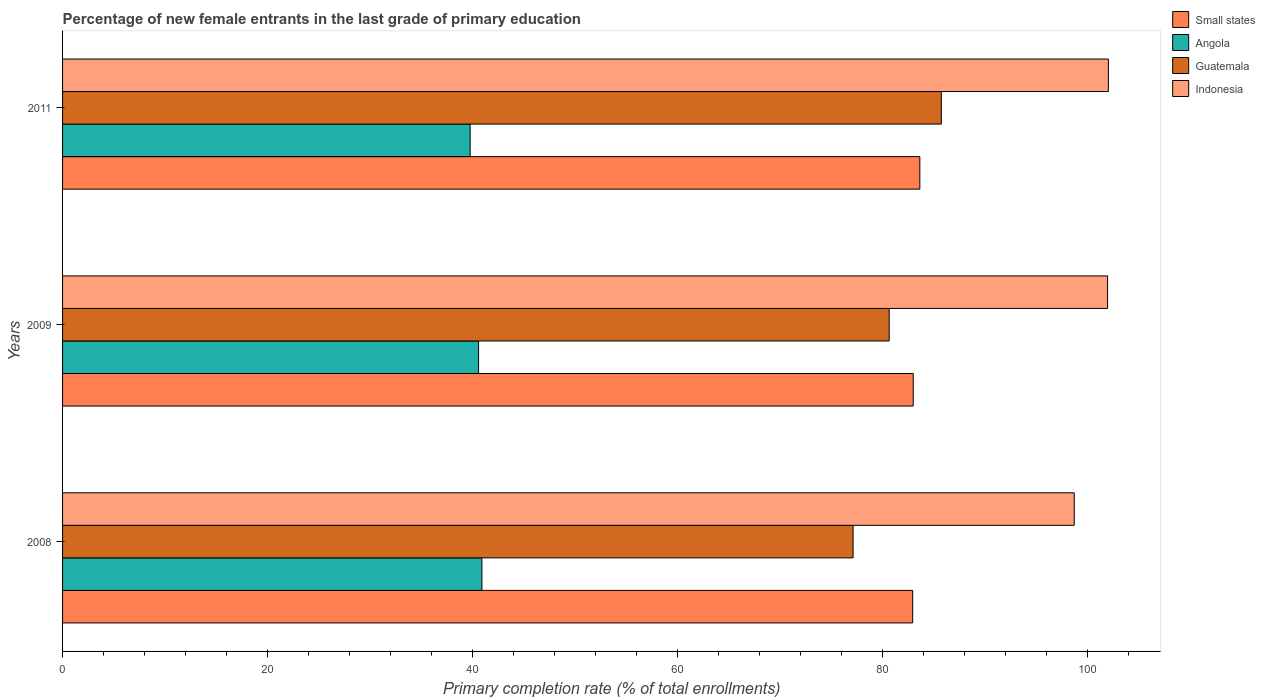Are the number of bars per tick equal to the number of legend labels?
Keep it short and to the point. Yes. How many bars are there on the 3rd tick from the top?
Your response must be concise. 4. How many bars are there on the 1st tick from the bottom?
Your answer should be very brief. 4. What is the percentage of new female entrants in Angola in 2009?
Keep it short and to the point. 40.6. Across all years, what is the maximum percentage of new female entrants in Angola?
Your answer should be very brief. 40.92. Across all years, what is the minimum percentage of new female entrants in Small states?
Your answer should be compact. 82.96. In which year was the percentage of new female entrants in Guatemala maximum?
Give a very brief answer. 2011. What is the total percentage of new female entrants in Guatemala in the graph?
Your answer should be very brief. 243.56. What is the difference between the percentage of new female entrants in Guatemala in 2008 and that in 2011?
Make the answer very short. -8.61. What is the difference between the percentage of new female entrants in Angola in 2009 and the percentage of new female entrants in Indonesia in 2011?
Provide a short and direct response. -61.46. What is the average percentage of new female entrants in Angola per year?
Ensure brevity in your answer.  40.43. In the year 2009, what is the difference between the percentage of new female entrants in Indonesia and percentage of new female entrants in Angola?
Offer a terse response. 61.38. What is the ratio of the percentage of new female entrants in Angola in 2008 to that in 2009?
Your answer should be compact. 1.01. Is the percentage of new female entrants in Indonesia in 2008 less than that in 2011?
Provide a short and direct response. Yes. What is the difference between the highest and the second highest percentage of new female entrants in Small states?
Make the answer very short. 0.65. What is the difference between the highest and the lowest percentage of new female entrants in Guatemala?
Give a very brief answer. 8.61. Is the sum of the percentage of new female entrants in Indonesia in 2008 and 2011 greater than the maximum percentage of new female entrants in Small states across all years?
Offer a very short reply. Yes. Is it the case that in every year, the sum of the percentage of new female entrants in Guatemala and percentage of new female entrants in Small states is greater than the sum of percentage of new female entrants in Indonesia and percentage of new female entrants in Angola?
Your response must be concise. Yes. What does the 1st bar from the top in 2011 represents?
Your answer should be compact. Indonesia. What does the 2nd bar from the bottom in 2011 represents?
Give a very brief answer. Angola. What is the difference between two consecutive major ticks on the X-axis?
Make the answer very short. 20. Are the values on the major ticks of X-axis written in scientific E-notation?
Offer a very short reply. No. Does the graph contain any zero values?
Ensure brevity in your answer.  No. Does the graph contain grids?
Offer a terse response. No. How many legend labels are there?
Provide a short and direct response. 4. What is the title of the graph?
Provide a short and direct response. Percentage of new female entrants in the last grade of primary education. Does "Israel" appear as one of the legend labels in the graph?
Keep it short and to the point. No. What is the label or title of the X-axis?
Offer a terse response. Primary completion rate (% of total enrollments). What is the Primary completion rate (% of total enrollments) of Small states in 2008?
Your answer should be compact. 82.96. What is the Primary completion rate (% of total enrollments) of Angola in 2008?
Make the answer very short. 40.92. What is the Primary completion rate (% of total enrollments) in Guatemala in 2008?
Make the answer very short. 77.14. What is the Primary completion rate (% of total enrollments) in Indonesia in 2008?
Your answer should be compact. 98.72. What is the Primary completion rate (% of total enrollments) in Small states in 2009?
Make the answer very short. 83.01. What is the Primary completion rate (% of total enrollments) in Angola in 2009?
Provide a succinct answer. 40.6. What is the Primary completion rate (% of total enrollments) in Guatemala in 2009?
Offer a terse response. 80.66. What is the Primary completion rate (% of total enrollments) of Indonesia in 2009?
Give a very brief answer. 101.98. What is the Primary completion rate (% of total enrollments) of Small states in 2011?
Keep it short and to the point. 83.66. What is the Primary completion rate (% of total enrollments) of Angola in 2011?
Keep it short and to the point. 39.77. What is the Primary completion rate (% of total enrollments) in Guatemala in 2011?
Keep it short and to the point. 85.75. What is the Primary completion rate (% of total enrollments) in Indonesia in 2011?
Provide a succinct answer. 102.05. Across all years, what is the maximum Primary completion rate (% of total enrollments) of Small states?
Ensure brevity in your answer.  83.66. Across all years, what is the maximum Primary completion rate (% of total enrollments) in Angola?
Offer a terse response. 40.92. Across all years, what is the maximum Primary completion rate (% of total enrollments) in Guatemala?
Provide a succinct answer. 85.75. Across all years, what is the maximum Primary completion rate (% of total enrollments) of Indonesia?
Offer a very short reply. 102.05. Across all years, what is the minimum Primary completion rate (% of total enrollments) in Small states?
Make the answer very short. 82.96. Across all years, what is the minimum Primary completion rate (% of total enrollments) of Angola?
Provide a succinct answer. 39.77. Across all years, what is the minimum Primary completion rate (% of total enrollments) in Guatemala?
Offer a very short reply. 77.14. Across all years, what is the minimum Primary completion rate (% of total enrollments) in Indonesia?
Your answer should be compact. 98.72. What is the total Primary completion rate (% of total enrollments) in Small states in the graph?
Provide a succinct answer. 249.63. What is the total Primary completion rate (% of total enrollments) of Angola in the graph?
Offer a very short reply. 121.29. What is the total Primary completion rate (% of total enrollments) of Guatemala in the graph?
Your answer should be very brief. 243.56. What is the total Primary completion rate (% of total enrollments) of Indonesia in the graph?
Your response must be concise. 302.76. What is the difference between the Primary completion rate (% of total enrollments) of Small states in 2008 and that in 2009?
Your answer should be compact. -0.05. What is the difference between the Primary completion rate (% of total enrollments) of Angola in 2008 and that in 2009?
Ensure brevity in your answer.  0.33. What is the difference between the Primary completion rate (% of total enrollments) of Guatemala in 2008 and that in 2009?
Ensure brevity in your answer.  -3.52. What is the difference between the Primary completion rate (% of total enrollments) in Indonesia in 2008 and that in 2009?
Your response must be concise. -3.25. What is the difference between the Primary completion rate (% of total enrollments) in Small states in 2008 and that in 2011?
Your response must be concise. -0.7. What is the difference between the Primary completion rate (% of total enrollments) in Angola in 2008 and that in 2011?
Your answer should be very brief. 1.15. What is the difference between the Primary completion rate (% of total enrollments) of Guatemala in 2008 and that in 2011?
Offer a terse response. -8.61. What is the difference between the Primary completion rate (% of total enrollments) of Indonesia in 2008 and that in 2011?
Provide a succinct answer. -3.33. What is the difference between the Primary completion rate (% of total enrollments) in Small states in 2009 and that in 2011?
Give a very brief answer. -0.65. What is the difference between the Primary completion rate (% of total enrollments) in Angola in 2009 and that in 2011?
Provide a short and direct response. 0.82. What is the difference between the Primary completion rate (% of total enrollments) in Guatemala in 2009 and that in 2011?
Your response must be concise. -5.09. What is the difference between the Primary completion rate (% of total enrollments) in Indonesia in 2009 and that in 2011?
Make the answer very short. -0.08. What is the difference between the Primary completion rate (% of total enrollments) of Small states in 2008 and the Primary completion rate (% of total enrollments) of Angola in 2009?
Your response must be concise. 42.36. What is the difference between the Primary completion rate (% of total enrollments) in Small states in 2008 and the Primary completion rate (% of total enrollments) in Guatemala in 2009?
Provide a short and direct response. 2.29. What is the difference between the Primary completion rate (% of total enrollments) of Small states in 2008 and the Primary completion rate (% of total enrollments) of Indonesia in 2009?
Your answer should be compact. -19.02. What is the difference between the Primary completion rate (% of total enrollments) of Angola in 2008 and the Primary completion rate (% of total enrollments) of Guatemala in 2009?
Provide a succinct answer. -39.74. What is the difference between the Primary completion rate (% of total enrollments) in Angola in 2008 and the Primary completion rate (% of total enrollments) in Indonesia in 2009?
Make the answer very short. -61.06. What is the difference between the Primary completion rate (% of total enrollments) in Guatemala in 2008 and the Primary completion rate (% of total enrollments) in Indonesia in 2009?
Give a very brief answer. -24.84. What is the difference between the Primary completion rate (% of total enrollments) of Small states in 2008 and the Primary completion rate (% of total enrollments) of Angola in 2011?
Give a very brief answer. 43.18. What is the difference between the Primary completion rate (% of total enrollments) in Small states in 2008 and the Primary completion rate (% of total enrollments) in Guatemala in 2011?
Your response must be concise. -2.79. What is the difference between the Primary completion rate (% of total enrollments) of Small states in 2008 and the Primary completion rate (% of total enrollments) of Indonesia in 2011?
Ensure brevity in your answer.  -19.1. What is the difference between the Primary completion rate (% of total enrollments) of Angola in 2008 and the Primary completion rate (% of total enrollments) of Guatemala in 2011?
Keep it short and to the point. -44.83. What is the difference between the Primary completion rate (% of total enrollments) of Angola in 2008 and the Primary completion rate (% of total enrollments) of Indonesia in 2011?
Your answer should be very brief. -61.13. What is the difference between the Primary completion rate (% of total enrollments) in Guatemala in 2008 and the Primary completion rate (% of total enrollments) in Indonesia in 2011?
Provide a succinct answer. -24.91. What is the difference between the Primary completion rate (% of total enrollments) of Small states in 2009 and the Primary completion rate (% of total enrollments) of Angola in 2011?
Keep it short and to the point. 43.24. What is the difference between the Primary completion rate (% of total enrollments) of Small states in 2009 and the Primary completion rate (% of total enrollments) of Guatemala in 2011?
Your response must be concise. -2.74. What is the difference between the Primary completion rate (% of total enrollments) of Small states in 2009 and the Primary completion rate (% of total enrollments) of Indonesia in 2011?
Provide a short and direct response. -19.04. What is the difference between the Primary completion rate (% of total enrollments) in Angola in 2009 and the Primary completion rate (% of total enrollments) in Guatemala in 2011?
Your response must be concise. -45.16. What is the difference between the Primary completion rate (% of total enrollments) of Angola in 2009 and the Primary completion rate (% of total enrollments) of Indonesia in 2011?
Provide a short and direct response. -61.46. What is the difference between the Primary completion rate (% of total enrollments) of Guatemala in 2009 and the Primary completion rate (% of total enrollments) of Indonesia in 2011?
Provide a short and direct response. -21.39. What is the average Primary completion rate (% of total enrollments) in Small states per year?
Your answer should be very brief. 83.21. What is the average Primary completion rate (% of total enrollments) of Angola per year?
Provide a short and direct response. 40.43. What is the average Primary completion rate (% of total enrollments) in Guatemala per year?
Ensure brevity in your answer.  81.19. What is the average Primary completion rate (% of total enrollments) in Indonesia per year?
Give a very brief answer. 100.92. In the year 2008, what is the difference between the Primary completion rate (% of total enrollments) of Small states and Primary completion rate (% of total enrollments) of Angola?
Offer a terse response. 42.04. In the year 2008, what is the difference between the Primary completion rate (% of total enrollments) in Small states and Primary completion rate (% of total enrollments) in Guatemala?
Offer a very short reply. 5.82. In the year 2008, what is the difference between the Primary completion rate (% of total enrollments) of Small states and Primary completion rate (% of total enrollments) of Indonesia?
Keep it short and to the point. -15.77. In the year 2008, what is the difference between the Primary completion rate (% of total enrollments) of Angola and Primary completion rate (% of total enrollments) of Guatemala?
Offer a terse response. -36.22. In the year 2008, what is the difference between the Primary completion rate (% of total enrollments) in Angola and Primary completion rate (% of total enrollments) in Indonesia?
Offer a very short reply. -57.8. In the year 2008, what is the difference between the Primary completion rate (% of total enrollments) in Guatemala and Primary completion rate (% of total enrollments) in Indonesia?
Provide a succinct answer. -21.58. In the year 2009, what is the difference between the Primary completion rate (% of total enrollments) of Small states and Primary completion rate (% of total enrollments) of Angola?
Give a very brief answer. 42.42. In the year 2009, what is the difference between the Primary completion rate (% of total enrollments) in Small states and Primary completion rate (% of total enrollments) in Guatemala?
Give a very brief answer. 2.35. In the year 2009, what is the difference between the Primary completion rate (% of total enrollments) in Small states and Primary completion rate (% of total enrollments) in Indonesia?
Make the answer very short. -18.97. In the year 2009, what is the difference between the Primary completion rate (% of total enrollments) of Angola and Primary completion rate (% of total enrollments) of Guatemala?
Offer a very short reply. -40.07. In the year 2009, what is the difference between the Primary completion rate (% of total enrollments) of Angola and Primary completion rate (% of total enrollments) of Indonesia?
Make the answer very short. -61.38. In the year 2009, what is the difference between the Primary completion rate (% of total enrollments) of Guatemala and Primary completion rate (% of total enrollments) of Indonesia?
Make the answer very short. -21.31. In the year 2011, what is the difference between the Primary completion rate (% of total enrollments) of Small states and Primary completion rate (% of total enrollments) of Angola?
Your response must be concise. 43.88. In the year 2011, what is the difference between the Primary completion rate (% of total enrollments) in Small states and Primary completion rate (% of total enrollments) in Guatemala?
Ensure brevity in your answer.  -2.1. In the year 2011, what is the difference between the Primary completion rate (% of total enrollments) of Small states and Primary completion rate (% of total enrollments) of Indonesia?
Provide a succinct answer. -18.4. In the year 2011, what is the difference between the Primary completion rate (% of total enrollments) of Angola and Primary completion rate (% of total enrollments) of Guatemala?
Keep it short and to the point. -45.98. In the year 2011, what is the difference between the Primary completion rate (% of total enrollments) of Angola and Primary completion rate (% of total enrollments) of Indonesia?
Offer a terse response. -62.28. In the year 2011, what is the difference between the Primary completion rate (% of total enrollments) in Guatemala and Primary completion rate (% of total enrollments) in Indonesia?
Offer a terse response. -16.3. What is the ratio of the Primary completion rate (% of total enrollments) in Angola in 2008 to that in 2009?
Your answer should be compact. 1.01. What is the ratio of the Primary completion rate (% of total enrollments) in Guatemala in 2008 to that in 2009?
Give a very brief answer. 0.96. What is the ratio of the Primary completion rate (% of total enrollments) in Indonesia in 2008 to that in 2009?
Your answer should be compact. 0.97. What is the ratio of the Primary completion rate (% of total enrollments) in Small states in 2008 to that in 2011?
Give a very brief answer. 0.99. What is the ratio of the Primary completion rate (% of total enrollments) of Angola in 2008 to that in 2011?
Offer a terse response. 1.03. What is the ratio of the Primary completion rate (% of total enrollments) of Guatemala in 2008 to that in 2011?
Provide a succinct answer. 0.9. What is the ratio of the Primary completion rate (% of total enrollments) of Indonesia in 2008 to that in 2011?
Give a very brief answer. 0.97. What is the ratio of the Primary completion rate (% of total enrollments) of Angola in 2009 to that in 2011?
Offer a very short reply. 1.02. What is the ratio of the Primary completion rate (% of total enrollments) in Guatemala in 2009 to that in 2011?
Keep it short and to the point. 0.94. What is the ratio of the Primary completion rate (% of total enrollments) in Indonesia in 2009 to that in 2011?
Give a very brief answer. 1. What is the difference between the highest and the second highest Primary completion rate (% of total enrollments) in Small states?
Offer a terse response. 0.65. What is the difference between the highest and the second highest Primary completion rate (% of total enrollments) in Angola?
Your answer should be compact. 0.33. What is the difference between the highest and the second highest Primary completion rate (% of total enrollments) of Guatemala?
Make the answer very short. 5.09. What is the difference between the highest and the second highest Primary completion rate (% of total enrollments) in Indonesia?
Ensure brevity in your answer.  0.08. What is the difference between the highest and the lowest Primary completion rate (% of total enrollments) in Small states?
Offer a very short reply. 0.7. What is the difference between the highest and the lowest Primary completion rate (% of total enrollments) of Angola?
Offer a very short reply. 1.15. What is the difference between the highest and the lowest Primary completion rate (% of total enrollments) of Guatemala?
Offer a terse response. 8.61. What is the difference between the highest and the lowest Primary completion rate (% of total enrollments) in Indonesia?
Your answer should be compact. 3.33. 